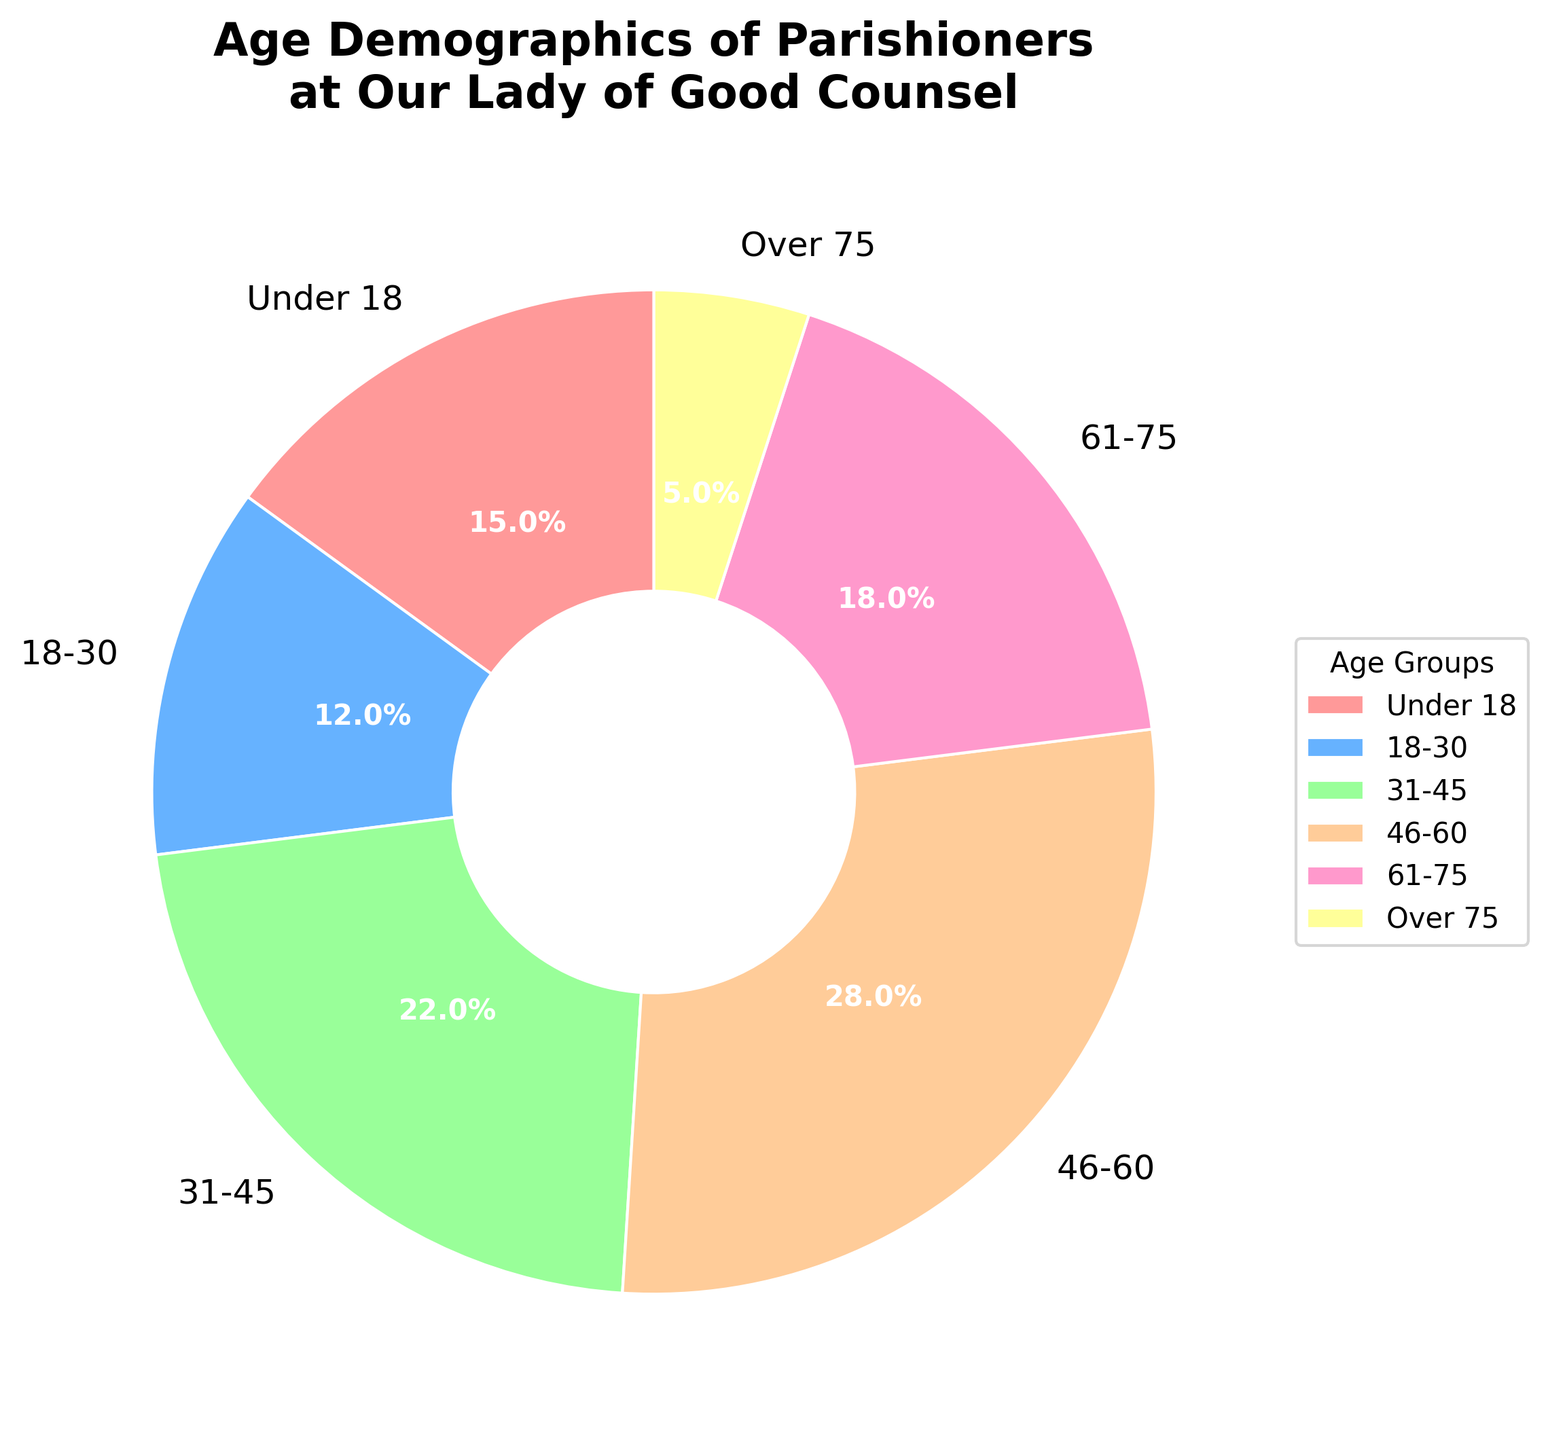What percentage of the parishioners are aged 18 to 30? The 18-30 age group has a slice labeled with "12%" in the figure.
Answer: 12% Which age group represents the largest portion of the parishioners? The "46-60" age group has the largest slice, labeled with "28%", making it the largest portion.
Answer: 46-60 What is the combined percentage of parishioners under 18 and over 75? The percentages for "Under 18" and "Over 75" are 15% and 5%, respectively. Adding them together gives 15% + 5% = 20%.
Answer: 20% How does the percentage of parishioners aged 31-45 compare to those aged 61-75? The figure shows the slice for ages 31-45 is labeled with "22%", and the slice for ages 61-75 is labeled with "18%". Thus, 22% is greater than 18%.
Answer: 31-45 group is greater Which age group has the smallest percentage and what is it? The "Over 75" age group has the smallest slice, labeled with "5%" in the figure.
Answer: Over 75, 5% What is the difference in percentage between the 31-45 and 46-60 age groups? The percentages are 22% for the 31-45 age group and 28% for the 46-60 age group. The difference is 28% - 22% = 6%.
Answer: 6% Which color represents the age group 46-60? The slice labeled "46-60" is represented by the color orange in the figure.
Answer: Orange What percentage of the parishioners are in the 46-60 category compared to the combined percentage of those in the 18-30 and 61-75 categories? The 46-60 age group has 28%. Adding the percentages for 18-30 (12%) and 61-75 (18%) gives a combined percentage of 12% + 18% = 30%. Therefore, 28% is less than 30%.
Answer: less 